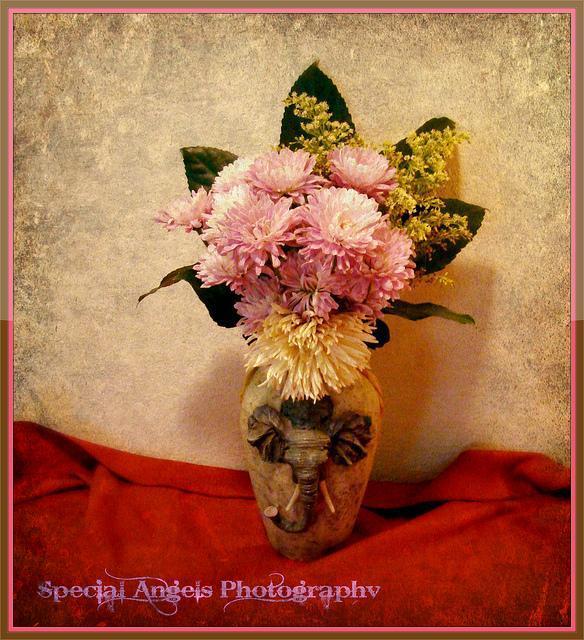How many vases are there?
Give a very brief answer. 1. How many cats are there?
Give a very brief answer. 0. 